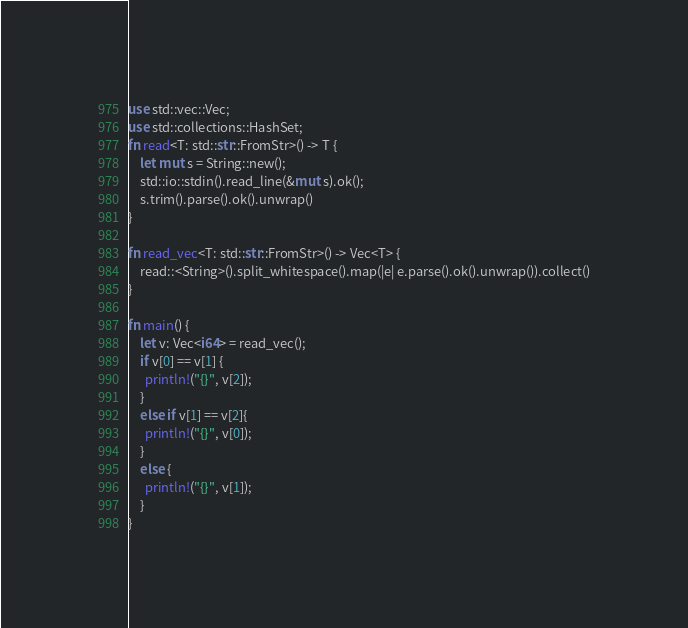Convert code to text. <code><loc_0><loc_0><loc_500><loc_500><_Rust_>use std::vec::Vec;
use std::collections::HashSet;
fn read<T: std::str::FromStr>() -> T {
    let mut s = String::new();
    std::io::stdin().read_line(&mut s).ok();
    s.trim().parse().ok().unwrap()
}

fn read_vec<T: std::str::FromStr>() -> Vec<T> {
    read::<String>().split_whitespace().map(|e| e.parse().ok().unwrap()).collect()
}

fn main() {
    let v: Vec<i64> = read_vec();
    if v[0] == v[1] {
      println!("{}", v[2]);
    }
    else if v[1] == v[2]{
      println!("{}", v[0]);
    }
    else {
      println!("{}", v[1]);
    }
}
</code> 